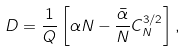<formula> <loc_0><loc_0><loc_500><loc_500>D = \frac { 1 } { Q } \left [ \alpha N - \frac { \bar { \alpha } } { N } C _ { N } ^ { 3 / 2 } \right ] ,</formula> 